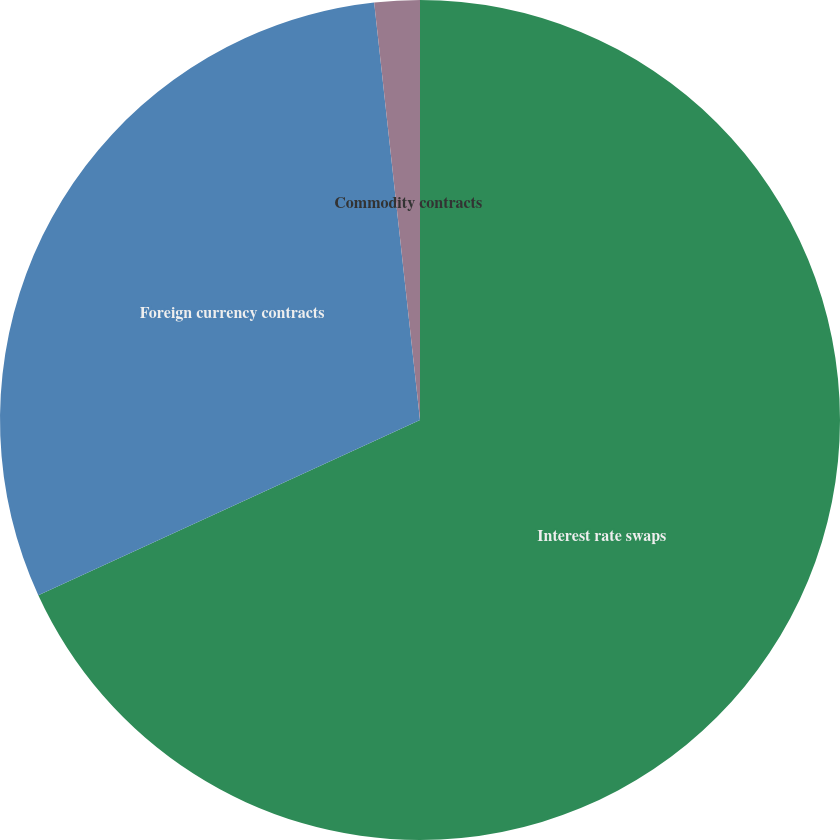Convert chart. <chart><loc_0><loc_0><loc_500><loc_500><pie_chart><fcel>Interest rate swaps<fcel>Foreign currency contracts<fcel>Commodity contracts<nl><fcel>68.15%<fcel>30.11%<fcel>1.74%<nl></chart> 